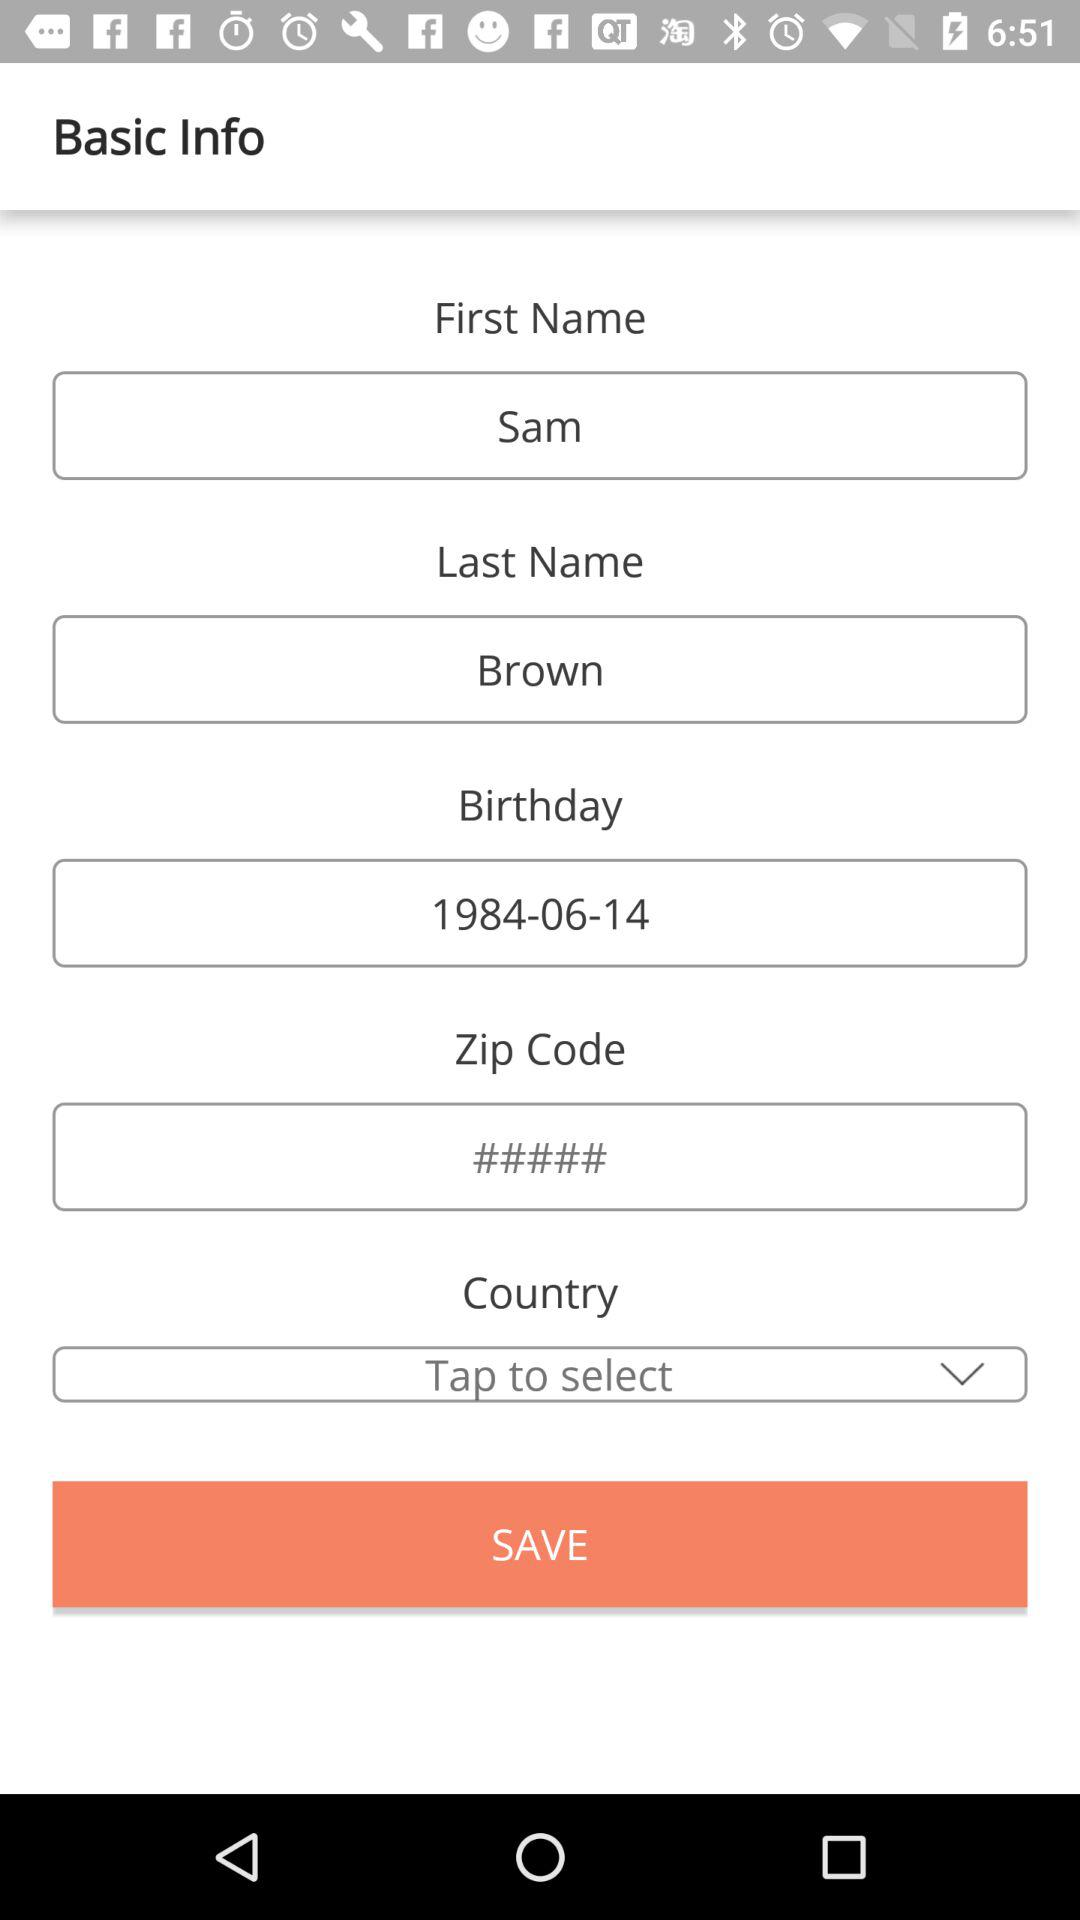What is the first name? The first name is Sam. 